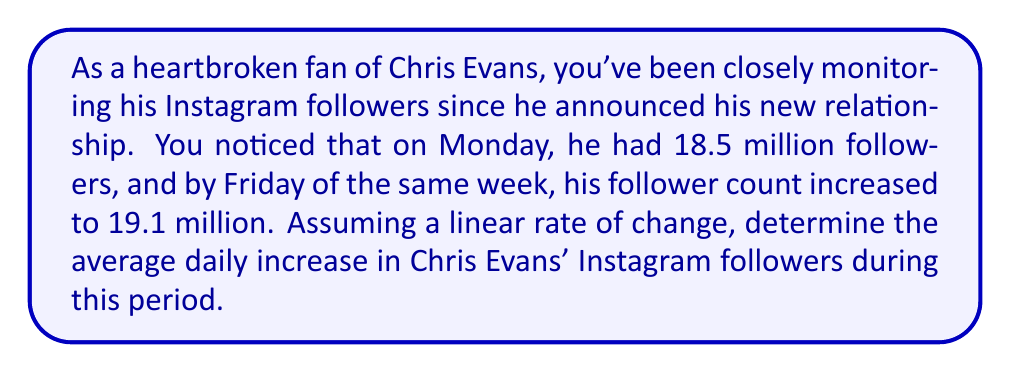Provide a solution to this math problem. To solve this problem, we need to calculate the rate of change in Chris Evans' Instagram followers over time. Let's break it down step by step:

1. Identify the given information:
   - Initial followers (Monday): 18.5 million
   - Final followers (Friday): 19.1 million
   - Time period: 5 days (from Monday to Friday, inclusive)

2. Calculate the total change in followers:
   $\text{Change in followers} = \text{Final followers} - \text{Initial followers}$
   $\text{Change in followers} = 19.1 \text{ million} - 18.5 \text{ million} = 0.6 \text{ million}$

3. Calculate the rate of change (average daily increase):
   The rate of change is given by the formula:
   $$\text{Rate of change} = \frac{\text{Change in y}}{\text{Change in x}} = \frac{\text{Change in followers}}{\text{Number of days}}$$

   Substituting the values:
   $$\text{Rate of change} = \frac{0.6 \text{ million}}{5 \text{ days}} = 0.12 \text{ million per day}$$

4. Convert the result to a more readable format:
   $0.12 \text{ million} = 120,000 \text{ followers per day}$

Therefore, the average daily increase in Chris Evans' Instagram followers during this period was 120,000 followers per day.
Answer: The average daily increase in Chris Evans' Instagram followers was 120,000 followers per day. 